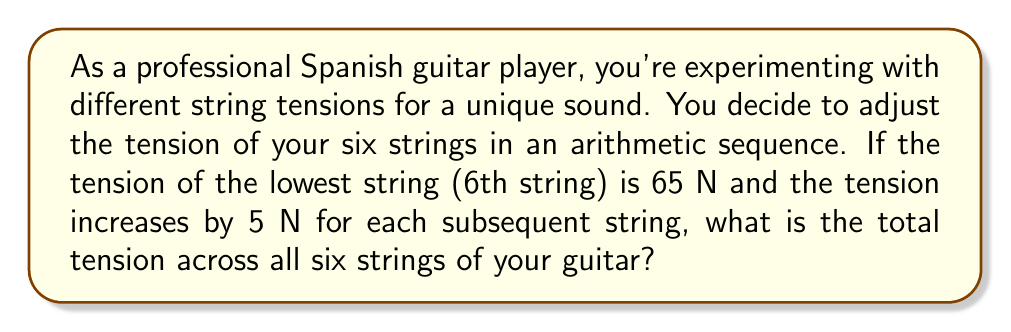Provide a solution to this math problem. Let's approach this step-by-step using the arithmetic sequence formula:

1) First, we identify the components of our arithmetic sequence:
   - $a_1 = 65$ N (first term, tension of the 6th string)
   - $d = 5$ N (common difference)
   - $n = 6$ (number of terms, as there are 6 strings)

2) The formula for the sum of an arithmetic sequence is:

   $$ S_n = \frac{n}{2}(a_1 + a_n) $$

   where $a_n$ is the last term of the sequence.

3) To find $a_n$, we use the arithmetic sequence term formula:

   $$ a_n = a_1 + (n-1)d $$

4) Substituting our values:

   $$ a_6 = 65 + (6-1)5 = 65 + 25 = 90 \text{ N} $$

5) Now we can use the sum formula:

   $$ S_6 = \frac{6}{2}(65 + 90) = 3(155) = 465 \text{ N} $$

Therefore, the total tension across all six strings is 465 N.
Answer: 465 N 